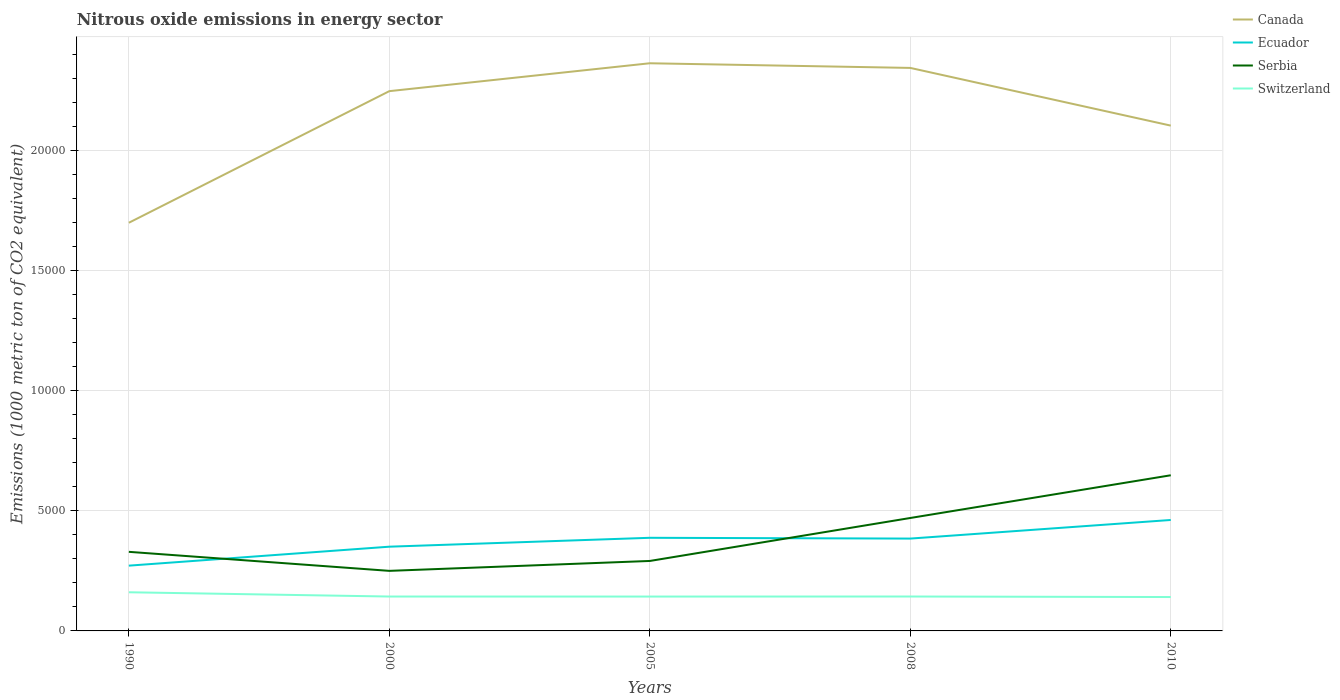How many different coloured lines are there?
Your answer should be very brief. 4. Is the number of lines equal to the number of legend labels?
Offer a terse response. Yes. Across all years, what is the maximum amount of nitrous oxide emitted in Switzerland?
Ensure brevity in your answer.  1411.6. In which year was the amount of nitrous oxide emitted in Switzerland maximum?
Offer a terse response. 2010. What is the total amount of nitrous oxide emitted in Switzerland in the graph?
Your response must be concise. 198.6. What is the difference between the highest and the second highest amount of nitrous oxide emitted in Ecuador?
Keep it short and to the point. 1902.1. What is the difference between the highest and the lowest amount of nitrous oxide emitted in Canada?
Offer a very short reply. 3. Is the amount of nitrous oxide emitted in Serbia strictly greater than the amount of nitrous oxide emitted in Ecuador over the years?
Your response must be concise. No. How many lines are there?
Your answer should be very brief. 4. How many years are there in the graph?
Provide a succinct answer. 5. Does the graph contain any zero values?
Ensure brevity in your answer.  No. Where does the legend appear in the graph?
Offer a very short reply. Top right. How many legend labels are there?
Give a very brief answer. 4. What is the title of the graph?
Your response must be concise. Nitrous oxide emissions in energy sector. Does "Lower middle income" appear as one of the legend labels in the graph?
Your response must be concise. No. What is the label or title of the Y-axis?
Ensure brevity in your answer.  Emissions (1000 metric ton of CO2 equivalent). What is the Emissions (1000 metric ton of CO2 equivalent) of Canada in 1990?
Provide a succinct answer. 1.70e+04. What is the Emissions (1000 metric ton of CO2 equivalent) of Ecuador in 1990?
Provide a short and direct response. 2718.5. What is the Emissions (1000 metric ton of CO2 equivalent) of Serbia in 1990?
Keep it short and to the point. 3293.8. What is the Emissions (1000 metric ton of CO2 equivalent) in Switzerland in 1990?
Your answer should be compact. 1610.2. What is the Emissions (1000 metric ton of CO2 equivalent) in Canada in 2000?
Make the answer very short. 2.25e+04. What is the Emissions (1000 metric ton of CO2 equivalent) of Ecuador in 2000?
Provide a short and direct response. 3508.3. What is the Emissions (1000 metric ton of CO2 equivalent) of Serbia in 2000?
Offer a terse response. 2501.4. What is the Emissions (1000 metric ton of CO2 equivalent) in Switzerland in 2000?
Keep it short and to the point. 1432.5. What is the Emissions (1000 metric ton of CO2 equivalent) of Canada in 2005?
Your answer should be compact. 2.36e+04. What is the Emissions (1000 metric ton of CO2 equivalent) in Ecuador in 2005?
Give a very brief answer. 3878.5. What is the Emissions (1000 metric ton of CO2 equivalent) in Serbia in 2005?
Your answer should be compact. 2913.8. What is the Emissions (1000 metric ton of CO2 equivalent) in Switzerland in 2005?
Offer a very short reply. 1431.1. What is the Emissions (1000 metric ton of CO2 equivalent) of Canada in 2008?
Offer a very short reply. 2.34e+04. What is the Emissions (1000 metric ton of CO2 equivalent) of Ecuador in 2008?
Offer a very short reply. 3846. What is the Emissions (1000 metric ton of CO2 equivalent) in Serbia in 2008?
Keep it short and to the point. 4703.6. What is the Emissions (1000 metric ton of CO2 equivalent) in Switzerland in 2008?
Give a very brief answer. 1433. What is the Emissions (1000 metric ton of CO2 equivalent) in Canada in 2010?
Give a very brief answer. 2.10e+04. What is the Emissions (1000 metric ton of CO2 equivalent) of Ecuador in 2010?
Your answer should be very brief. 4620.6. What is the Emissions (1000 metric ton of CO2 equivalent) of Serbia in 2010?
Ensure brevity in your answer.  6482.7. What is the Emissions (1000 metric ton of CO2 equivalent) of Switzerland in 2010?
Your answer should be compact. 1411.6. Across all years, what is the maximum Emissions (1000 metric ton of CO2 equivalent) of Canada?
Offer a very short reply. 2.36e+04. Across all years, what is the maximum Emissions (1000 metric ton of CO2 equivalent) of Ecuador?
Provide a succinct answer. 4620.6. Across all years, what is the maximum Emissions (1000 metric ton of CO2 equivalent) of Serbia?
Provide a short and direct response. 6482.7. Across all years, what is the maximum Emissions (1000 metric ton of CO2 equivalent) of Switzerland?
Provide a short and direct response. 1610.2. Across all years, what is the minimum Emissions (1000 metric ton of CO2 equivalent) in Canada?
Provide a short and direct response. 1.70e+04. Across all years, what is the minimum Emissions (1000 metric ton of CO2 equivalent) in Ecuador?
Provide a short and direct response. 2718.5. Across all years, what is the minimum Emissions (1000 metric ton of CO2 equivalent) of Serbia?
Offer a very short reply. 2501.4. Across all years, what is the minimum Emissions (1000 metric ton of CO2 equivalent) in Switzerland?
Offer a very short reply. 1411.6. What is the total Emissions (1000 metric ton of CO2 equivalent) of Canada in the graph?
Your answer should be compact. 1.08e+05. What is the total Emissions (1000 metric ton of CO2 equivalent) in Ecuador in the graph?
Your response must be concise. 1.86e+04. What is the total Emissions (1000 metric ton of CO2 equivalent) in Serbia in the graph?
Ensure brevity in your answer.  1.99e+04. What is the total Emissions (1000 metric ton of CO2 equivalent) of Switzerland in the graph?
Provide a succinct answer. 7318.4. What is the difference between the Emissions (1000 metric ton of CO2 equivalent) of Canada in 1990 and that in 2000?
Provide a succinct answer. -5481.4. What is the difference between the Emissions (1000 metric ton of CO2 equivalent) of Ecuador in 1990 and that in 2000?
Make the answer very short. -789.8. What is the difference between the Emissions (1000 metric ton of CO2 equivalent) of Serbia in 1990 and that in 2000?
Your response must be concise. 792.4. What is the difference between the Emissions (1000 metric ton of CO2 equivalent) of Switzerland in 1990 and that in 2000?
Your answer should be compact. 177.7. What is the difference between the Emissions (1000 metric ton of CO2 equivalent) in Canada in 1990 and that in 2005?
Provide a succinct answer. -6642.6. What is the difference between the Emissions (1000 metric ton of CO2 equivalent) in Ecuador in 1990 and that in 2005?
Offer a terse response. -1160. What is the difference between the Emissions (1000 metric ton of CO2 equivalent) of Serbia in 1990 and that in 2005?
Your answer should be compact. 380. What is the difference between the Emissions (1000 metric ton of CO2 equivalent) of Switzerland in 1990 and that in 2005?
Offer a terse response. 179.1. What is the difference between the Emissions (1000 metric ton of CO2 equivalent) in Canada in 1990 and that in 2008?
Give a very brief answer. -6448.9. What is the difference between the Emissions (1000 metric ton of CO2 equivalent) in Ecuador in 1990 and that in 2008?
Your answer should be compact. -1127.5. What is the difference between the Emissions (1000 metric ton of CO2 equivalent) of Serbia in 1990 and that in 2008?
Provide a short and direct response. -1409.8. What is the difference between the Emissions (1000 metric ton of CO2 equivalent) of Switzerland in 1990 and that in 2008?
Provide a short and direct response. 177.2. What is the difference between the Emissions (1000 metric ton of CO2 equivalent) in Canada in 1990 and that in 2010?
Keep it short and to the point. -4045.7. What is the difference between the Emissions (1000 metric ton of CO2 equivalent) in Ecuador in 1990 and that in 2010?
Your answer should be very brief. -1902.1. What is the difference between the Emissions (1000 metric ton of CO2 equivalent) in Serbia in 1990 and that in 2010?
Offer a terse response. -3188.9. What is the difference between the Emissions (1000 metric ton of CO2 equivalent) of Switzerland in 1990 and that in 2010?
Provide a short and direct response. 198.6. What is the difference between the Emissions (1000 metric ton of CO2 equivalent) in Canada in 2000 and that in 2005?
Offer a terse response. -1161.2. What is the difference between the Emissions (1000 metric ton of CO2 equivalent) of Ecuador in 2000 and that in 2005?
Make the answer very short. -370.2. What is the difference between the Emissions (1000 metric ton of CO2 equivalent) of Serbia in 2000 and that in 2005?
Give a very brief answer. -412.4. What is the difference between the Emissions (1000 metric ton of CO2 equivalent) in Canada in 2000 and that in 2008?
Keep it short and to the point. -967.5. What is the difference between the Emissions (1000 metric ton of CO2 equivalent) in Ecuador in 2000 and that in 2008?
Ensure brevity in your answer.  -337.7. What is the difference between the Emissions (1000 metric ton of CO2 equivalent) in Serbia in 2000 and that in 2008?
Offer a terse response. -2202.2. What is the difference between the Emissions (1000 metric ton of CO2 equivalent) of Canada in 2000 and that in 2010?
Provide a succinct answer. 1435.7. What is the difference between the Emissions (1000 metric ton of CO2 equivalent) of Ecuador in 2000 and that in 2010?
Your response must be concise. -1112.3. What is the difference between the Emissions (1000 metric ton of CO2 equivalent) of Serbia in 2000 and that in 2010?
Ensure brevity in your answer.  -3981.3. What is the difference between the Emissions (1000 metric ton of CO2 equivalent) of Switzerland in 2000 and that in 2010?
Provide a short and direct response. 20.9. What is the difference between the Emissions (1000 metric ton of CO2 equivalent) in Canada in 2005 and that in 2008?
Your answer should be compact. 193.7. What is the difference between the Emissions (1000 metric ton of CO2 equivalent) in Ecuador in 2005 and that in 2008?
Offer a terse response. 32.5. What is the difference between the Emissions (1000 metric ton of CO2 equivalent) of Serbia in 2005 and that in 2008?
Make the answer very short. -1789.8. What is the difference between the Emissions (1000 metric ton of CO2 equivalent) of Switzerland in 2005 and that in 2008?
Provide a succinct answer. -1.9. What is the difference between the Emissions (1000 metric ton of CO2 equivalent) of Canada in 2005 and that in 2010?
Make the answer very short. 2596.9. What is the difference between the Emissions (1000 metric ton of CO2 equivalent) in Ecuador in 2005 and that in 2010?
Offer a very short reply. -742.1. What is the difference between the Emissions (1000 metric ton of CO2 equivalent) of Serbia in 2005 and that in 2010?
Offer a terse response. -3568.9. What is the difference between the Emissions (1000 metric ton of CO2 equivalent) in Switzerland in 2005 and that in 2010?
Keep it short and to the point. 19.5. What is the difference between the Emissions (1000 metric ton of CO2 equivalent) in Canada in 2008 and that in 2010?
Keep it short and to the point. 2403.2. What is the difference between the Emissions (1000 metric ton of CO2 equivalent) in Ecuador in 2008 and that in 2010?
Offer a terse response. -774.6. What is the difference between the Emissions (1000 metric ton of CO2 equivalent) in Serbia in 2008 and that in 2010?
Offer a very short reply. -1779.1. What is the difference between the Emissions (1000 metric ton of CO2 equivalent) of Switzerland in 2008 and that in 2010?
Provide a succinct answer. 21.4. What is the difference between the Emissions (1000 metric ton of CO2 equivalent) of Canada in 1990 and the Emissions (1000 metric ton of CO2 equivalent) of Ecuador in 2000?
Make the answer very short. 1.35e+04. What is the difference between the Emissions (1000 metric ton of CO2 equivalent) of Canada in 1990 and the Emissions (1000 metric ton of CO2 equivalent) of Serbia in 2000?
Your answer should be compact. 1.45e+04. What is the difference between the Emissions (1000 metric ton of CO2 equivalent) of Canada in 1990 and the Emissions (1000 metric ton of CO2 equivalent) of Switzerland in 2000?
Provide a succinct answer. 1.56e+04. What is the difference between the Emissions (1000 metric ton of CO2 equivalent) in Ecuador in 1990 and the Emissions (1000 metric ton of CO2 equivalent) in Serbia in 2000?
Make the answer very short. 217.1. What is the difference between the Emissions (1000 metric ton of CO2 equivalent) of Ecuador in 1990 and the Emissions (1000 metric ton of CO2 equivalent) of Switzerland in 2000?
Ensure brevity in your answer.  1286. What is the difference between the Emissions (1000 metric ton of CO2 equivalent) of Serbia in 1990 and the Emissions (1000 metric ton of CO2 equivalent) of Switzerland in 2000?
Provide a short and direct response. 1861.3. What is the difference between the Emissions (1000 metric ton of CO2 equivalent) in Canada in 1990 and the Emissions (1000 metric ton of CO2 equivalent) in Ecuador in 2005?
Offer a very short reply. 1.31e+04. What is the difference between the Emissions (1000 metric ton of CO2 equivalent) in Canada in 1990 and the Emissions (1000 metric ton of CO2 equivalent) in Serbia in 2005?
Your answer should be very brief. 1.41e+04. What is the difference between the Emissions (1000 metric ton of CO2 equivalent) of Canada in 1990 and the Emissions (1000 metric ton of CO2 equivalent) of Switzerland in 2005?
Offer a very short reply. 1.56e+04. What is the difference between the Emissions (1000 metric ton of CO2 equivalent) of Ecuador in 1990 and the Emissions (1000 metric ton of CO2 equivalent) of Serbia in 2005?
Your answer should be compact. -195.3. What is the difference between the Emissions (1000 metric ton of CO2 equivalent) of Ecuador in 1990 and the Emissions (1000 metric ton of CO2 equivalent) of Switzerland in 2005?
Provide a succinct answer. 1287.4. What is the difference between the Emissions (1000 metric ton of CO2 equivalent) in Serbia in 1990 and the Emissions (1000 metric ton of CO2 equivalent) in Switzerland in 2005?
Your answer should be compact. 1862.7. What is the difference between the Emissions (1000 metric ton of CO2 equivalent) of Canada in 1990 and the Emissions (1000 metric ton of CO2 equivalent) of Ecuador in 2008?
Give a very brief answer. 1.32e+04. What is the difference between the Emissions (1000 metric ton of CO2 equivalent) in Canada in 1990 and the Emissions (1000 metric ton of CO2 equivalent) in Serbia in 2008?
Your answer should be compact. 1.23e+04. What is the difference between the Emissions (1000 metric ton of CO2 equivalent) of Canada in 1990 and the Emissions (1000 metric ton of CO2 equivalent) of Switzerland in 2008?
Provide a succinct answer. 1.56e+04. What is the difference between the Emissions (1000 metric ton of CO2 equivalent) in Ecuador in 1990 and the Emissions (1000 metric ton of CO2 equivalent) in Serbia in 2008?
Your response must be concise. -1985.1. What is the difference between the Emissions (1000 metric ton of CO2 equivalent) in Ecuador in 1990 and the Emissions (1000 metric ton of CO2 equivalent) in Switzerland in 2008?
Ensure brevity in your answer.  1285.5. What is the difference between the Emissions (1000 metric ton of CO2 equivalent) of Serbia in 1990 and the Emissions (1000 metric ton of CO2 equivalent) of Switzerland in 2008?
Make the answer very short. 1860.8. What is the difference between the Emissions (1000 metric ton of CO2 equivalent) of Canada in 1990 and the Emissions (1000 metric ton of CO2 equivalent) of Ecuador in 2010?
Keep it short and to the point. 1.24e+04. What is the difference between the Emissions (1000 metric ton of CO2 equivalent) in Canada in 1990 and the Emissions (1000 metric ton of CO2 equivalent) in Serbia in 2010?
Give a very brief answer. 1.05e+04. What is the difference between the Emissions (1000 metric ton of CO2 equivalent) in Canada in 1990 and the Emissions (1000 metric ton of CO2 equivalent) in Switzerland in 2010?
Give a very brief answer. 1.56e+04. What is the difference between the Emissions (1000 metric ton of CO2 equivalent) of Ecuador in 1990 and the Emissions (1000 metric ton of CO2 equivalent) of Serbia in 2010?
Give a very brief answer. -3764.2. What is the difference between the Emissions (1000 metric ton of CO2 equivalent) of Ecuador in 1990 and the Emissions (1000 metric ton of CO2 equivalent) of Switzerland in 2010?
Give a very brief answer. 1306.9. What is the difference between the Emissions (1000 metric ton of CO2 equivalent) in Serbia in 1990 and the Emissions (1000 metric ton of CO2 equivalent) in Switzerland in 2010?
Your response must be concise. 1882.2. What is the difference between the Emissions (1000 metric ton of CO2 equivalent) in Canada in 2000 and the Emissions (1000 metric ton of CO2 equivalent) in Ecuador in 2005?
Offer a terse response. 1.86e+04. What is the difference between the Emissions (1000 metric ton of CO2 equivalent) of Canada in 2000 and the Emissions (1000 metric ton of CO2 equivalent) of Serbia in 2005?
Your answer should be compact. 1.96e+04. What is the difference between the Emissions (1000 metric ton of CO2 equivalent) of Canada in 2000 and the Emissions (1000 metric ton of CO2 equivalent) of Switzerland in 2005?
Your answer should be compact. 2.10e+04. What is the difference between the Emissions (1000 metric ton of CO2 equivalent) of Ecuador in 2000 and the Emissions (1000 metric ton of CO2 equivalent) of Serbia in 2005?
Provide a succinct answer. 594.5. What is the difference between the Emissions (1000 metric ton of CO2 equivalent) of Ecuador in 2000 and the Emissions (1000 metric ton of CO2 equivalent) of Switzerland in 2005?
Provide a succinct answer. 2077.2. What is the difference between the Emissions (1000 metric ton of CO2 equivalent) of Serbia in 2000 and the Emissions (1000 metric ton of CO2 equivalent) of Switzerland in 2005?
Offer a terse response. 1070.3. What is the difference between the Emissions (1000 metric ton of CO2 equivalent) in Canada in 2000 and the Emissions (1000 metric ton of CO2 equivalent) in Ecuador in 2008?
Make the answer very short. 1.86e+04. What is the difference between the Emissions (1000 metric ton of CO2 equivalent) of Canada in 2000 and the Emissions (1000 metric ton of CO2 equivalent) of Serbia in 2008?
Your answer should be very brief. 1.78e+04. What is the difference between the Emissions (1000 metric ton of CO2 equivalent) of Canada in 2000 and the Emissions (1000 metric ton of CO2 equivalent) of Switzerland in 2008?
Your response must be concise. 2.10e+04. What is the difference between the Emissions (1000 metric ton of CO2 equivalent) of Ecuador in 2000 and the Emissions (1000 metric ton of CO2 equivalent) of Serbia in 2008?
Your response must be concise. -1195.3. What is the difference between the Emissions (1000 metric ton of CO2 equivalent) of Ecuador in 2000 and the Emissions (1000 metric ton of CO2 equivalent) of Switzerland in 2008?
Offer a very short reply. 2075.3. What is the difference between the Emissions (1000 metric ton of CO2 equivalent) in Serbia in 2000 and the Emissions (1000 metric ton of CO2 equivalent) in Switzerland in 2008?
Your response must be concise. 1068.4. What is the difference between the Emissions (1000 metric ton of CO2 equivalent) in Canada in 2000 and the Emissions (1000 metric ton of CO2 equivalent) in Ecuador in 2010?
Offer a very short reply. 1.79e+04. What is the difference between the Emissions (1000 metric ton of CO2 equivalent) in Canada in 2000 and the Emissions (1000 metric ton of CO2 equivalent) in Serbia in 2010?
Give a very brief answer. 1.60e+04. What is the difference between the Emissions (1000 metric ton of CO2 equivalent) in Canada in 2000 and the Emissions (1000 metric ton of CO2 equivalent) in Switzerland in 2010?
Make the answer very short. 2.11e+04. What is the difference between the Emissions (1000 metric ton of CO2 equivalent) of Ecuador in 2000 and the Emissions (1000 metric ton of CO2 equivalent) of Serbia in 2010?
Keep it short and to the point. -2974.4. What is the difference between the Emissions (1000 metric ton of CO2 equivalent) in Ecuador in 2000 and the Emissions (1000 metric ton of CO2 equivalent) in Switzerland in 2010?
Your answer should be compact. 2096.7. What is the difference between the Emissions (1000 metric ton of CO2 equivalent) in Serbia in 2000 and the Emissions (1000 metric ton of CO2 equivalent) in Switzerland in 2010?
Provide a short and direct response. 1089.8. What is the difference between the Emissions (1000 metric ton of CO2 equivalent) in Canada in 2005 and the Emissions (1000 metric ton of CO2 equivalent) in Ecuador in 2008?
Make the answer very short. 1.98e+04. What is the difference between the Emissions (1000 metric ton of CO2 equivalent) in Canada in 2005 and the Emissions (1000 metric ton of CO2 equivalent) in Serbia in 2008?
Keep it short and to the point. 1.89e+04. What is the difference between the Emissions (1000 metric ton of CO2 equivalent) in Canada in 2005 and the Emissions (1000 metric ton of CO2 equivalent) in Switzerland in 2008?
Keep it short and to the point. 2.22e+04. What is the difference between the Emissions (1000 metric ton of CO2 equivalent) in Ecuador in 2005 and the Emissions (1000 metric ton of CO2 equivalent) in Serbia in 2008?
Offer a very short reply. -825.1. What is the difference between the Emissions (1000 metric ton of CO2 equivalent) in Ecuador in 2005 and the Emissions (1000 metric ton of CO2 equivalent) in Switzerland in 2008?
Give a very brief answer. 2445.5. What is the difference between the Emissions (1000 metric ton of CO2 equivalent) of Serbia in 2005 and the Emissions (1000 metric ton of CO2 equivalent) of Switzerland in 2008?
Your response must be concise. 1480.8. What is the difference between the Emissions (1000 metric ton of CO2 equivalent) of Canada in 2005 and the Emissions (1000 metric ton of CO2 equivalent) of Ecuador in 2010?
Ensure brevity in your answer.  1.90e+04. What is the difference between the Emissions (1000 metric ton of CO2 equivalent) in Canada in 2005 and the Emissions (1000 metric ton of CO2 equivalent) in Serbia in 2010?
Offer a very short reply. 1.72e+04. What is the difference between the Emissions (1000 metric ton of CO2 equivalent) in Canada in 2005 and the Emissions (1000 metric ton of CO2 equivalent) in Switzerland in 2010?
Keep it short and to the point. 2.22e+04. What is the difference between the Emissions (1000 metric ton of CO2 equivalent) of Ecuador in 2005 and the Emissions (1000 metric ton of CO2 equivalent) of Serbia in 2010?
Offer a terse response. -2604.2. What is the difference between the Emissions (1000 metric ton of CO2 equivalent) in Ecuador in 2005 and the Emissions (1000 metric ton of CO2 equivalent) in Switzerland in 2010?
Your response must be concise. 2466.9. What is the difference between the Emissions (1000 metric ton of CO2 equivalent) of Serbia in 2005 and the Emissions (1000 metric ton of CO2 equivalent) of Switzerland in 2010?
Offer a very short reply. 1502.2. What is the difference between the Emissions (1000 metric ton of CO2 equivalent) of Canada in 2008 and the Emissions (1000 metric ton of CO2 equivalent) of Ecuador in 2010?
Your response must be concise. 1.88e+04. What is the difference between the Emissions (1000 metric ton of CO2 equivalent) of Canada in 2008 and the Emissions (1000 metric ton of CO2 equivalent) of Serbia in 2010?
Keep it short and to the point. 1.70e+04. What is the difference between the Emissions (1000 metric ton of CO2 equivalent) of Canada in 2008 and the Emissions (1000 metric ton of CO2 equivalent) of Switzerland in 2010?
Offer a very short reply. 2.20e+04. What is the difference between the Emissions (1000 metric ton of CO2 equivalent) of Ecuador in 2008 and the Emissions (1000 metric ton of CO2 equivalent) of Serbia in 2010?
Your answer should be very brief. -2636.7. What is the difference between the Emissions (1000 metric ton of CO2 equivalent) in Ecuador in 2008 and the Emissions (1000 metric ton of CO2 equivalent) in Switzerland in 2010?
Ensure brevity in your answer.  2434.4. What is the difference between the Emissions (1000 metric ton of CO2 equivalent) in Serbia in 2008 and the Emissions (1000 metric ton of CO2 equivalent) in Switzerland in 2010?
Keep it short and to the point. 3292. What is the average Emissions (1000 metric ton of CO2 equivalent) in Canada per year?
Keep it short and to the point. 2.15e+04. What is the average Emissions (1000 metric ton of CO2 equivalent) in Ecuador per year?
Offer a terse response. 3714.38. What is the average Emissions (1000 metric ton of CO2 equivalent) of Serbia per year?
Give a very brief answer. 3979.06. What is the average Emissions (1000 metric ton of CO2 equivalent) in Switzerland per year?
Offer a very short reply. 1463.68. In the year 1990, what is the difference between the Emissions (1000 metric ton of CO2 equivalent) in Canada and Emissions (1000 metric ton of CO2 equivalent) in Ecuador?
Make the answer very short. 1.43e+04. In the year 1990, what is the difference between the Emissions (1000 metric ton of CO2 equivalent) of Canada and Emissions (1000 metric ton of CO2 equivalent) of Serbia?
Your answer should be very brief. 1.37e+04. In the year 1990, what is the difference between the Emissions (1000 metric ton of CO2 equivalent) of Canada and Emissions (1000 metric ton of CO2 equivalent) of Switzerland?
Offer a very short reply. 1.54e+04. In the year 1990, what is the difference between the Emissions (1000 metric ton of CO2 equivalent) of Ecuador and Emissions (1000 metric ton of CO2 equivalent) of Serbia?
Ensure brevity in your answer.  -575.3. In the year 1990, what is the difference between the Emissions (1000 metric ton of CO2 equivalent) in Ecuador and Emissions (1000 metric ton of CO2 equivalent) in Switzerland?
Keep it short and to the point. 1108.3. In the year 1990, what is the difference between the Emissions (1000 metric ton of CO2 equivalent) in Serbia and Emissions (1000 metric ton of CO2 equivalent) in Switzerland?
Offer a terse response. 1683.6. In the year 2000, what is the difference between the Emissions (1000 metric ton of CO2 equivalent) of Canada and Emissions (1000 metric ton of CO2 equivalent) of Ecuador?
Your answer should be compact. 1.90e+04. In the year 2000, what is the difference between the Emissions (1000 metric ton of CO2 equivalent) of Canada and Emissions (1000 metric ton of CO2 equivalent) of Serbia?
Your response must be concise. 2.00e+04. In the year 2000, what is the difference between the Emissions (1000 metric ton of CO2 equivalent) in Canada and Emissions (1000 metric ton of CO2 equivalent) in Switzerland?
Your answer should be very brief. 2.10e+04. In the year 2000, what is the difference between the Emissions (1000 metric ton of CO2 equivalent) of Ecuador and Emissions (1000 metric ton of CO2 equivalent) of Serbia?
Offer a very short reply. 1006.9. In the year 2000, what is the difference between the Emissions (1000 metric ton of CO2 equivalent) in Ecuador and Emissions (1000 metric ton of CO2 equivalent) in Switzerland?
Ensure brevity in your answer.  2075.8. In the year 2000, what is the difference between the Emissions (1000 metric ton of CO2 equivalent) in Serbia and Emissions (1000 metric ton of CO2 equivalent) in Switzerland?
Your answer should be compact. 1068.9. In the year 2005, what is the difference between the Emissions (1000 metric ton of CO2 equivalent) of Canada and Emissions (1000 metric ton of CO2 equivalent) of Ecuador?
Give a very brief answer. 1.98e+04. In the year 2005, what is the difference between the Emissions (1000 metric ton of CO2 equivalent) of Canada and Emissions (1000 metric ton of CO2 equivalent) of Serbia?
Your response must be concise. 2.07e+04. In the year 2005, what is the difference between the Emissions (1000 metric ton of CO2 equivalent) in Canada and Emissions (1000 metric ton of CO2 equivalent) in Switzerland?
Keep it short and to the point. 2.22e+04. In the year 2005, what is the difference between the Emissions (1000 metric ton of CO2 equivalent) in Ecuador and Emissions (1000 metric ton of CO2 equivalent) in Serbia?
Offer a terse response. 964.7. In the year 2005, what is the difference between the Emissions (1000 metric ton of CO2 equivalent) in Ecuador and Emissions (1000 metric ton of CO2 equivalent) in Switzerland?
Your answer should be compact. 2447.4. In the year 2005, what is the difference between the Emissions (1000 metric ton of CO2 equivalent) in Serbia and Emissions (1000 metric ton of CO2 equivalent) in Switzerland?
Offer a terse response. 1482.7. In the year 2008, what is the difference between the Emissions (1000 metric ton of CO2 equivalent) in Canada and Emissions (1000 metric ton of CO2 equivalent) in Ecuador?
Keep it short and to the point. 1.96e+04. In the year 2008, what is the difference between the Emissions (1000 metric ton of CO2 equivalent) in Canada and Emissions (1000 metric ton of CO2 equivalent) in Serbia?
Keep it short and to the point. 1.87e+04. In the year 2008, what is the difference between the Emissions (1000 metric ton of CO2 equivalent) in Canada and Emissions (1000 metric ton of CO2 equivalent) in Switzerland?
Ensure brevity in your answer.  2.20e+04. In the year 2008, what is the difference between the Emissions (1000 metric ton of CO2 equivalent) of Ecuador and Emissions (1000 metric ton of CO2 equivalent) of Serbia?
Provide a short and direct response. -857.6. In the year 2008, what is the difference between the Emissions (1000 metric ton of CO2 equivalent) of Ecuador and Emissions (1000 metric ton of CO2 equivalent) of Switzerland?
Provide a short and direct response. 2413. In the year 2008, what is the difference between the Emissions (1000 metric ton of CO2 equivalent) of Serbia and Emissions (1000 metric ton of CO2 equivalent) of Switzerland?
Provide a short and direct response. 3270.6. In the year 2010, what is the difference between the Emissions (1000 metric ton of CO2 equivalent) of Canada and Emissions (1000 metric ton of CO2 equivalent) of Ecuador?
Offer a terse response. 1.64e+04. In the year 2010, what is the difference between the Emissions (1000 metric ton of CO2 equivalent) in Canada and Emissions (1000 metric ton of CO2 equivalent) in Serbia?
Provide a short and direct response. 1.46e+04. In the year 2010, what is the difference between the Emissions (1000 metric ton of CO2 equivalent) of Canada and Emissions (1000 metric ton of CO2 equivalent) of Switzerland?
Your response must be concise. 1.96e+04. In the year 2010, what is the difference between the Emissions (1000 metric ton of CO2 equivalent) in Ecuador and Emissions (1000 metric ton of CO2 equivalent) in Serbia?
Offer a terse response. -1862.1. In the year 2010, what is the difference between the Emissions (1000 metric ton of CO2 equivalent) in Ecuador and Emissions (1000 metric ton of CO2 equivalent) in Switzerland?
Your answer should be very brief. 3209. In the year 2010, what is the difference between the Emissions (1000 metric ton of CO2 equivalent) of Serbia and Emissions (1000 metric ton of CO2 equivalent) of Switzerland?
Make the answer very short. 5071.1. What is the ratio of the Emissions (1000 metric ton of CO2 equivalent) of Canada in 1990 to that in 2000?
Your answer should be very brief. 0.76. What is the ratio of the Emissions (1000 metric ton of CO2 equivalent) of Ecuador in 1990 to that in 2000?
Your response must be concise. 0.77. What is the ratio of the Emissions (1000 metric ton of CO2 equivalent) in Serbia in 1990 to that in 2000?
Your answer should be very brief. 1.32. What is the ratio of the Emissions (1000 metric ton of CO2 equivalent) in Switzerland in 1990 to that in 2000?
Your answer should be very brief. 1.12. What is the ratio of the Emissions (1000 metric ton of CO2 equivalent) in Canada in 1990 to that in 2005?
Give a very brief answer. 0.72. What is the ratio of the Emissions (1000 metric ton of CO2 equivalent) in Ecuador in 1990 to that in 2005?
Give a very brief answer. 0.7. What is the ratio of the Emissions (1000 metric ton of CO2 equivalent) in Serbia in 1990 to that in 2005?
Ensure brevity in your answer.  1.13. What is the ratio of the Emissions (1000 metric ton of CO2 equivalent) in Switzerland in 1990 to that in 2005?
Ensure brevity in your answer.  1.13. What is the ratio of the Emissions (1000 metric ton of CO2 equivalent) of Canada in 1990 to that in 2008?
Offer a terse response. 0.72. What is the ratio of the Emissions (1000 metric ton of CO2 equivalent) of Ecuador in 1990 to that in 2008?
Offer a terse response. 0.71. What is the ratio of the Emissions (1000 metric ton of CO2 equivalent) of Serbia in 1990 to that in 2008?
Give a very brief answer. 0.7. What is the ratio of the Emissions (1000 metric ton of CO2 equivalent) of Switzerland in 1990 to that in 2008?
Your answer should be compact. 1.12. What is the ratio of the Emissions (1000 metric ton of CO2 equivalent) of Canada in 1990 to that in 2010?
Ensure brevity in your answer.  0.81. What is the ratio of the Emissions (1000 metric ton of CO2 equivalent) of Ecuador in 1990 to that in 2010?
Your answer should be compact. 0.59. What is the ratio of the Emissions (1000 metric ton of CO2 equivalent) of Serbia in 1990 to that in 2010?
Keep it short and to the point. 0.51. What is the ratio of the Emissions (1000 metric ton of CO2 equivalent) in Switzerland in 1990 to that in 2010?
Offer a very short reply. 1.14. What is the ratio of the Emissions (1000 metric ton of CO2 equivalent) of Canada in 2000 to that in 2005?
Your answer should be compact. 0.95. What is the ratio of the Emissions (1000 metric ton of CO2 equivalent) in Ecuador in 2000 to that in 2005?
Your response must be concise. 0.9. What is the ratio of the Emissions (1000 metric ton of CO2 equivalent) of Serbia in 2000 to that in 2005?
Make the answer very short. 0.86. What is the ratio of the Emissions (1000 metric ton of CO2 equivalent) of Switzerland in 2000 to that in 2005?
Keep it short and to the point. 1. What is the ratio of the Emissions (1000 metric ton of CO2 equivalent) in Canada in 2000 to that in 2008?
Keep it short and to the point. 0.96. What is the ratio of the Emissions (1000 metric ton of CO2 equivalent) of Ecuador in 2000 to that in 2008?
Offer a very short reply. 0.91. What is the ratio of the Emissions (1000 metric ton of CO2 equivalent) in Serbia in 2000 to that in 2008?
Offer a very short reply. 0.53. What is the ratio of the Emissions (1000 metric ton of CO2 equivalent) in Canada in 2000 to that in 2010?
Ensure brevity in your answer.  1.07. What is the ratio of the Emissions (1000 metric ton of CO2 equivalent) of Ecuador in 2000 to that in 2010?
Offer a very short reply. 0.76. What is the ratio of the Emissions (1000 metric ton of CO2 equivalent) of Serbia in 2000 to that in 2010?
Offer a terse response. 0.39. What is the ratio of the Emissions (1000 metric ton of CO2 equivalent) of Switzerland in 2000 to that in 2010?
Your answer should be very brief. 1.01. What is the ratio of the Emissions (1000 metric ton of CO2 equivalent) of Canada in 2005 to that in 2008?
Keep it short and to the point. 1.01. What is the ratio of the Emissions (1000 metric ton of CO2 equivalent) of Ecuador in 2005 to that in 2008?
Keep it short and to the point. 1.01. What is the ratio of the Emissions (1000 metric ton of CO2 equivalent) of Serbia in 2005 to that in 2008?
Provide a succinct answer. 0.62. What is the ratio of the Emissions (1000 metric ton of CO2 equivalent) of Canada in 2005 to that in 2010?
Ensure brevity in your answer.  1.12. What is the ratio of the Emissions (1000 metric ton of CO2 equivalent) of Ecuador in 2005 to that in 2010?
Offer a very short reply. 0.84. What is the ratio of the Emissions (1000 metric ton of CO2 equivalent) of Serbia in 2005 to that in 2010?
Ensure brevity in your answer.  0.45. What is the ratio of the Emissions (1000 metric ton of CO2 equivalent) in Switzerland in 2005 to that in 2010?
Offer a terse response. 1.01. What is the ratio of the Emissions (1000 metric ton of CO2 equivalent) in Canada in 2008 to that in 2010?
Offer a terse response. 1.11. What is the ratio of the Emissions (1000 metric ton of CO2 equivalent) of Ecuador in 2008 to that in 2010?
Offer a very short reply. 0.83. What is the ratio of the Emissions (1000 metric ton of CO2 equivalent) in Serbia in 2008 to that in 2010?
Offer a terse response. 0.73. What is the ratio of the Emissions (1000 metric ton of CO2 equivalent) of Switzerland in 2008 to that in 2010?
Give a very brief answer. 1.02. What is the difference between the highest and the second highest Emissions (1000 metric ton of CO2 equivalent) of Canada?
Offer a terse response. 193.7. What is the difference between the highest and the second highest Emissions (1000 metric ton of CO2 equivalent) of Ecuador?
Your answer should be very brief. 742.1. What is the difference between the highest and the second highest Emissions (1000 metric ton of CO2 equivalent) of Serbia?
Provide a short and direct response. 1779.1. What is the difference between the highest and the second highest Emissions (1000 metric ton of CO2 equivalent) in Switzerland?
Your answer should be compact. 177.2. What is the difference between the highest and the lowest Emissions (1000 metric ton of CO2 equivalent) in Canada?
Your answer should be very brief. 6642.6. What is the difference between the highest and the lowest Emissions (1000 metric ton of CO2 equivalent) of Ecuador?
Make the answer very short. 1902.1. What is the difference between the highest and the lowest Emissions (1000 metric ton of CO2 equivalent) in Serbia?
Make the answer very short. 3981.3. What is the difference between the highest and the lowest Emissions (1000 metric ton of CO2 equivalent) of Switzerland?
Keep it short and to the point. 198.6. 